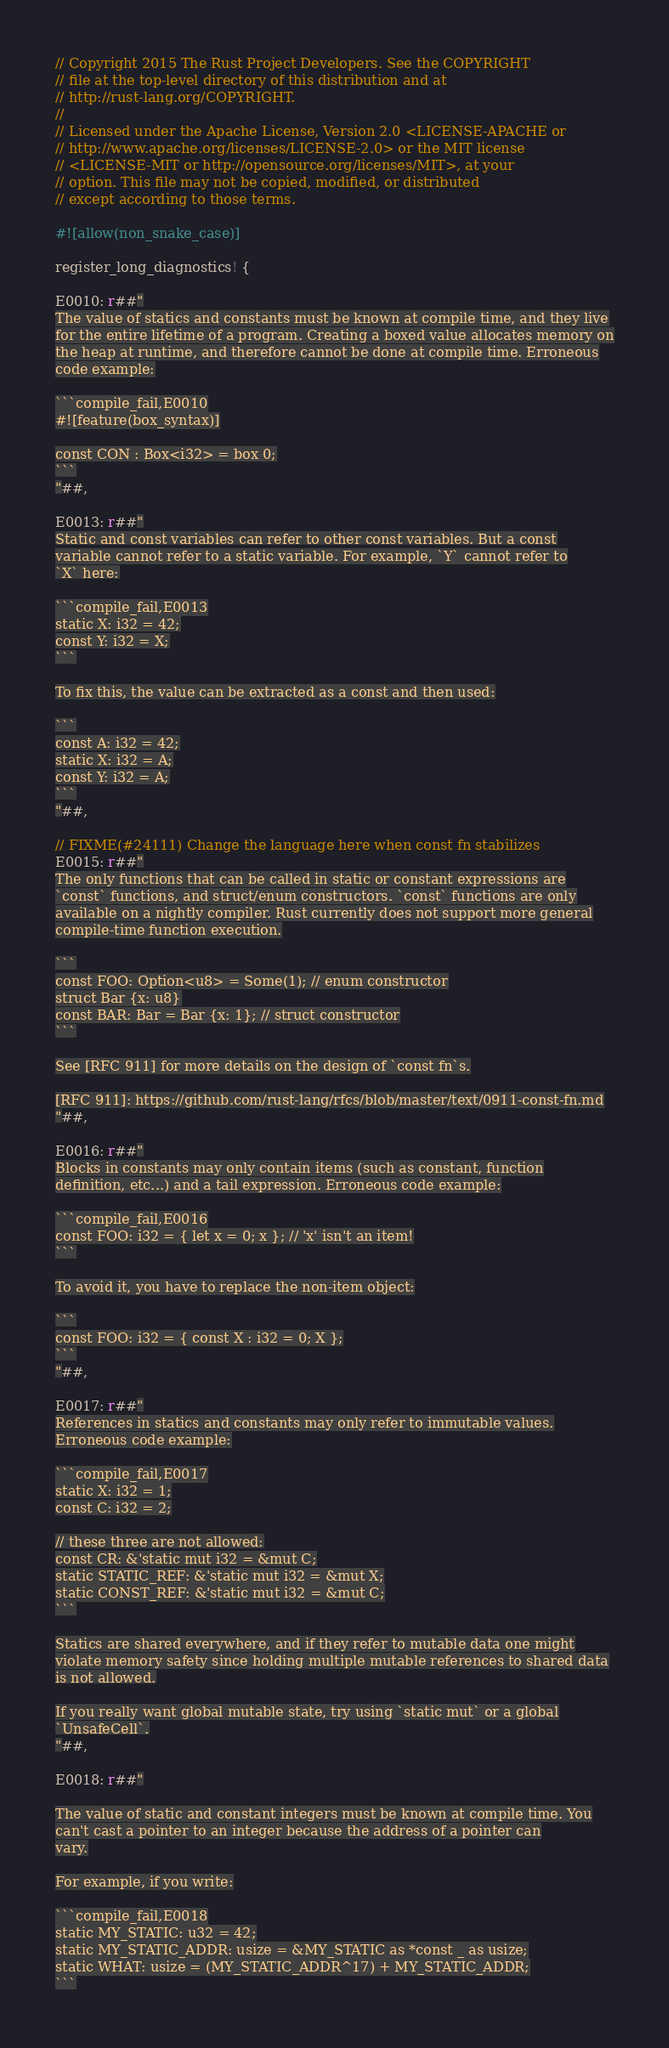<code> <loc_0><loc_0><loc_500><loc_500><_Rust_>// Copyright 2015 The Rust Project Developers. See the COPYRIGHT
// file at the top-level directory of this distribution and at
// http://rust-lang.org/COPYRIGHT.
//
// Licensed under the Apache License, Version 2.0 <LICENSE-APACHE or
// http://www.apache.org/licenses/LICENSE-2.0> or the MIT license
// <LICENSE-MIT or http://opensource.org/licenses/MIT>, at your
// option. This file may not be copied, modified, or distributed
// except according to those terms.

#![allow(non_snake_case)]

register_long_diagnostics! {

E0010: r##"
The value of statics and constants must be known at compile time, and they live
for the entire lifetime of a program. Creating a boxed value allocates memory on
the heap at runtime, and therefore cannot be done at compile time. Erroneous
code example:

```compile_fail,E0010
#![feature(box_syntax)]

const CON : Box<i32> = box 0;
```
"##,

E0013: r##"
Static and const variables can refer to other const variables. But a const
variable cannot refer to a static variable. For example, `Y` cannot refer to
`X` here:

```compile_fail,E0013
static X: i32 = 42;
const Y: i32 = X;
```

To fix this, the value can be extracted as a const and then used:

```
const A: i32 = 42;
static X: i32 = A;
const Y: i32 = A;
```
"##,

// FIXME(#24111) Change the language here when const fn stabilizes
E0015: r##"
The only functions that can be called in static or constant expressions are
`const` functions, and struct/enum constructors. `const` functions are only
available on a nightly compiler. Rust currently does not support more general
compile-time function execution.

```
const FOO: Option<u8> = Some(1); // enum constructor
struct Bar {x: u8}
const BAR: Bar = Bar {x: 1}; // struct constructor
```

See [RFC 911] for more details on the design of `const fn`s.

[RFC 911]: https://github.com/rust-lang/rfcs/blob/master/text/0911-const-fn.md
"##,

E0016: r##"
Blocks in constants may only contain items (such as constant, function
definition, etc...) and a tail expression. Erroneous code example:

```compile_fail,E0016
const FOO: i32 = { let x = 0; x }; // 'x' isn't an item!
```

To avoid it, you have to replace the non-item object:

```
const FOO: i32 = { const X : i32 = 0; X };
```
"##,

E0017: r##"
References in statics and constants may only refer to immutable values.
Erroneous code example:

```compile_fail,E0017
static X: i32 = 1;
const C: i32 = 2;

// these three are not allowed:
const CR: &'static mut i32 = &mut C;
static STATIC_REF: &'static mut i32 = &mut X;
static CONST_REF: &'static mut i32 = &mut C;
```

Statics are shared everywhere, and if they refer to mutable data one might
violate memory safety since holding multiple mutable references to shared data
is not allowed.

If you really want global mutable state, try using `static mut` or a global
`UnsafeCell`.
"##,

E0018: r##"

The value of static and constant integers must be known at compile time. You
can't cast a pointer to an integer because the address of a pointer can
vary.

For example, if you write:

```compile_fail,E0018
static MY_STATIC: u32 = 42;
static MY_STATIC_ADDR: usize = &MY_STATIC as *const _ as usize;
static WHAT: usize = (MY_STATIC_ADDR^17) + MY_STATIC_ADDR;
```
</code> 